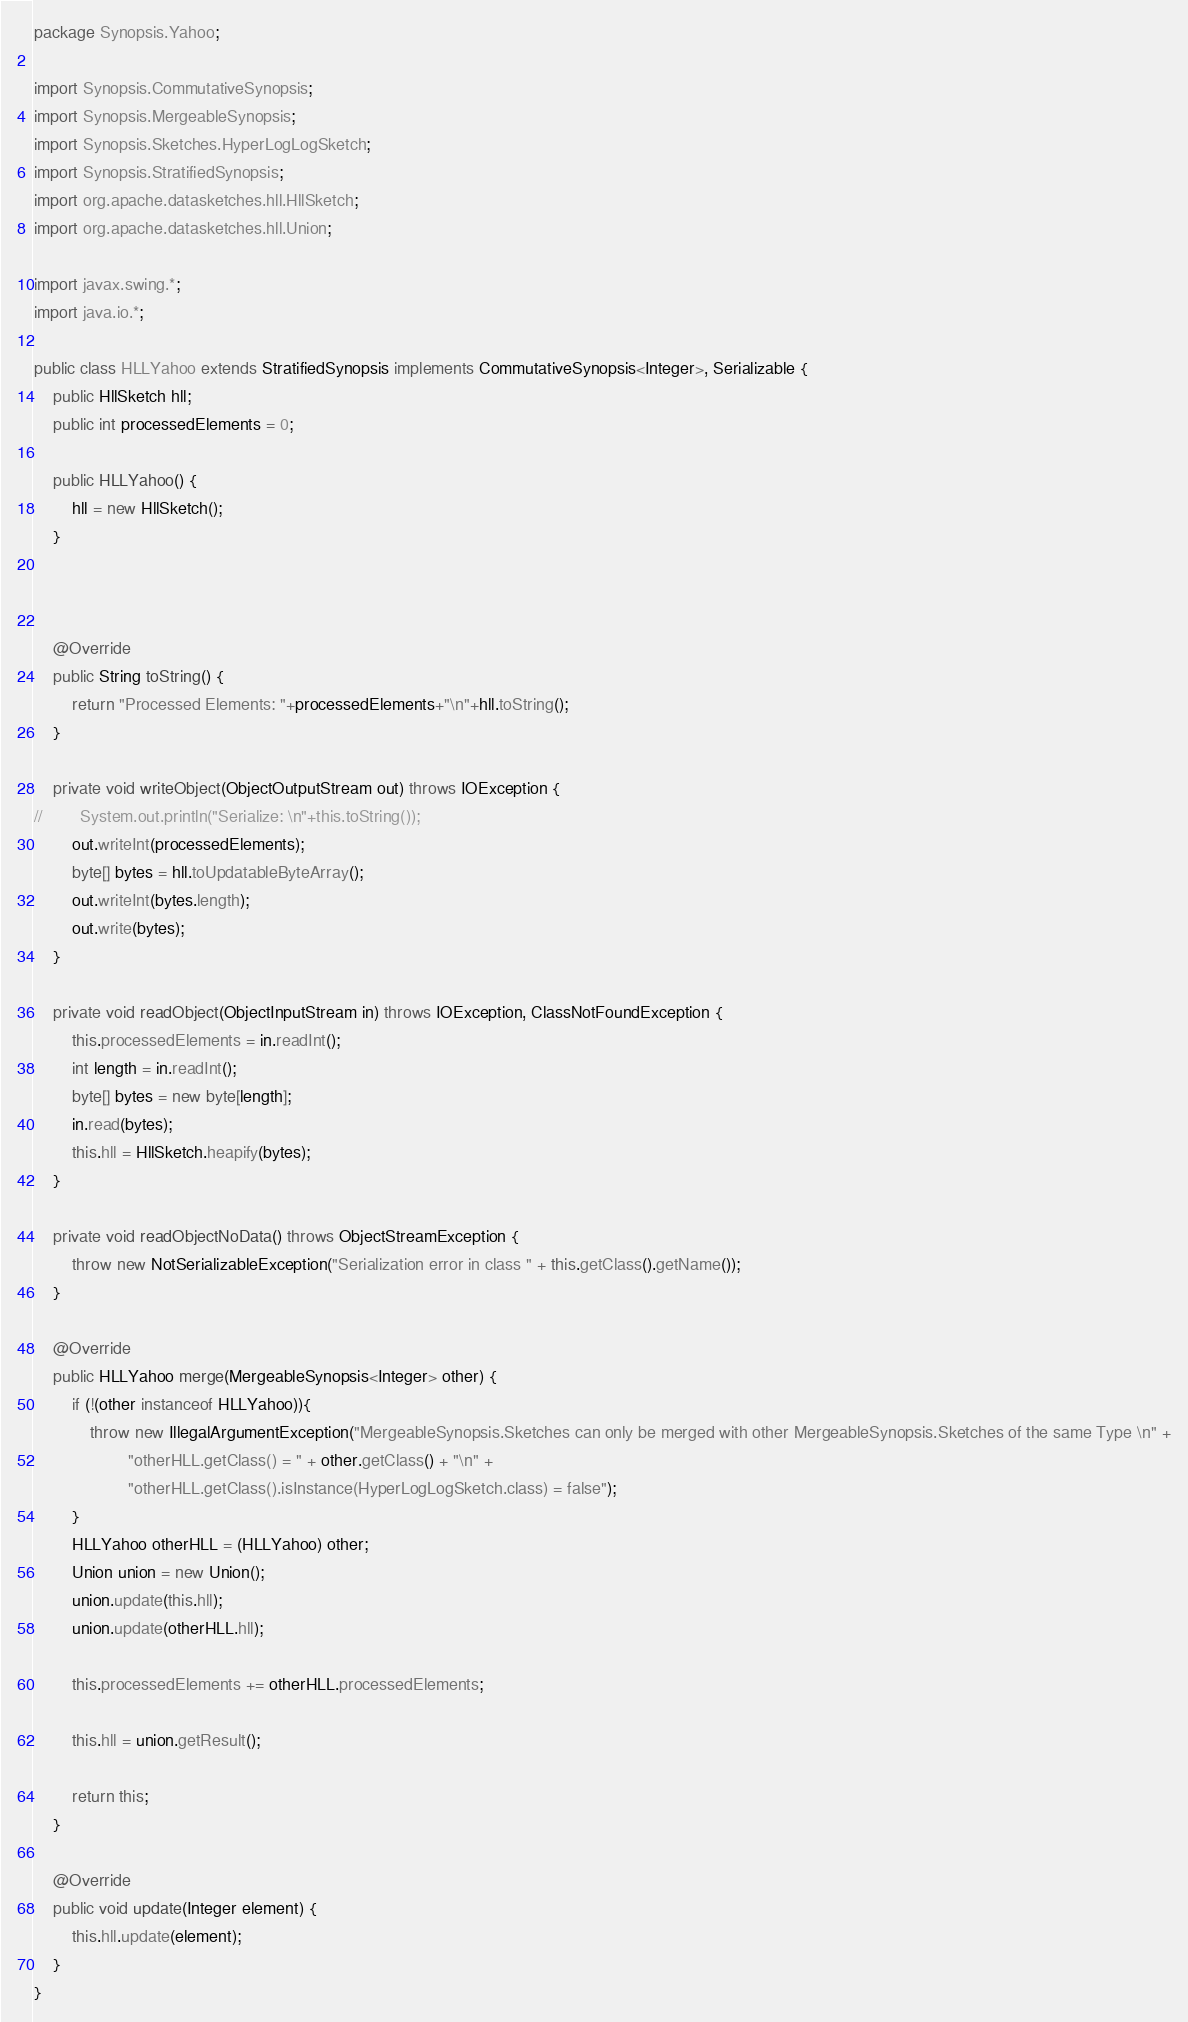Convert code to text. <code><loc_0><loc_0><loc_500><loc_500><_Java_>package Synopsis.Yahoo;

import Synopsis.CommutativeSynopsis;
import Synopsis.MergeableSynopsis;
import Synopsis.Sketches.HyperLogLogSketch;
import Synopsis.StratifiedSynopsis;
import org.apache.datasketches.hll.HllSketch;
import org.apache.datasketches.hll.Union;

import javax.swing.*;
import java.io.*;

public class HLLYahoo extends StratifiedSynopsis implements CommutativeSynopsis<Integer>, Serializable {
    public HllSketch hll;
    public int processedElements = 0;

    public HLLYahoo() {
        hll = new HllSketch();
    }



    @Override
    public String toString() {
        return "Processed Elements: "+processedElements+"\n"+hll.toString();
    }

    private void writeObject(ObjectOutputStream out) throws IOException {
//        System.out.println("Serialize: \n"+this.toString());
        out.writeInt(processedElements);
        byte[] bytes = hll.toUpdatableByteArray();
        out.writeInt(bytes.length);
        out.write(bytes);
    }

    private void readObject(ObjectInputStream in) throws IOException, ClassNotFoundException {
        this.processedElements = in.readInt();
        int length = in.readInt();
        byte[] bytes = new byte[length];
        in.read(bytes);
        this.hll = HllSketch.heapify(bytes);
    }

    private void readObjectNoData() throws ObjectStreamException {
        throw new NotSerializableException("Serialization error in class " + this.getClass().getName());
    }

    @Override
    public HLLYahoo merge(MergeableSynopsis<Integer> other) {
        if (!(other instanceof HLLYahoo)){
            throw new IllegalArgumentException("MergeableSynopsis.Sketches can only be merged with other MergeableSynopsis.Sketches of the same Type \n" +
                    "otherHLL.getClass() = " + other.getClass() + "\n" +
                    "otherHLL.getClass().isInstance(HyperLogLogSketch.class) = false");
        }
        HLLYahoo otherHLL = (HLLYahoo) other;
        Union union = new Union();
        union.update(this.hll);
        union.update(otherHLL.hll);

        this.processedElements += otherHLL.processedElements;

        this.hll = union.getResult();

        return this;
    }

    @Override
    public void update(Integer element) {
        this.hll.update(element);
    }
}
</code> 